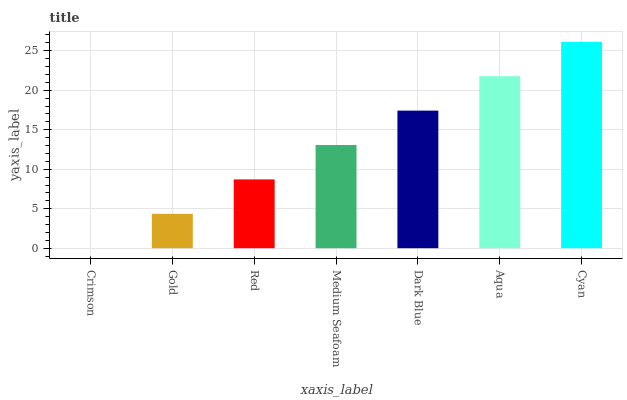Is Crimson the minimum?
Answer yes or no. Yes. Is Cyan the maximum?
Answer yes or no. Yes. Is Gold the minimum?
Answer yes or no. No. Is Gold the maximum?
Answer yes or no. No. Is Gold greater than Crimson?
Answer yes or no. Yes. Is Crimson less than Gold?
Answer yes or no. Yes. Is Crimson greater than Gold?
Answer yes or no. No. Is Gold less than Crimson?
Answer yes or no. No. Is Medium Seafoam the high median?
Answer yes or no. Yes. Is Medium Seafoam the low median?
Answer yes or no. Yes. Is Aqua the high median?
Answer yes or no. No. Is Aqua the low median?
Answer yes or no. No. 